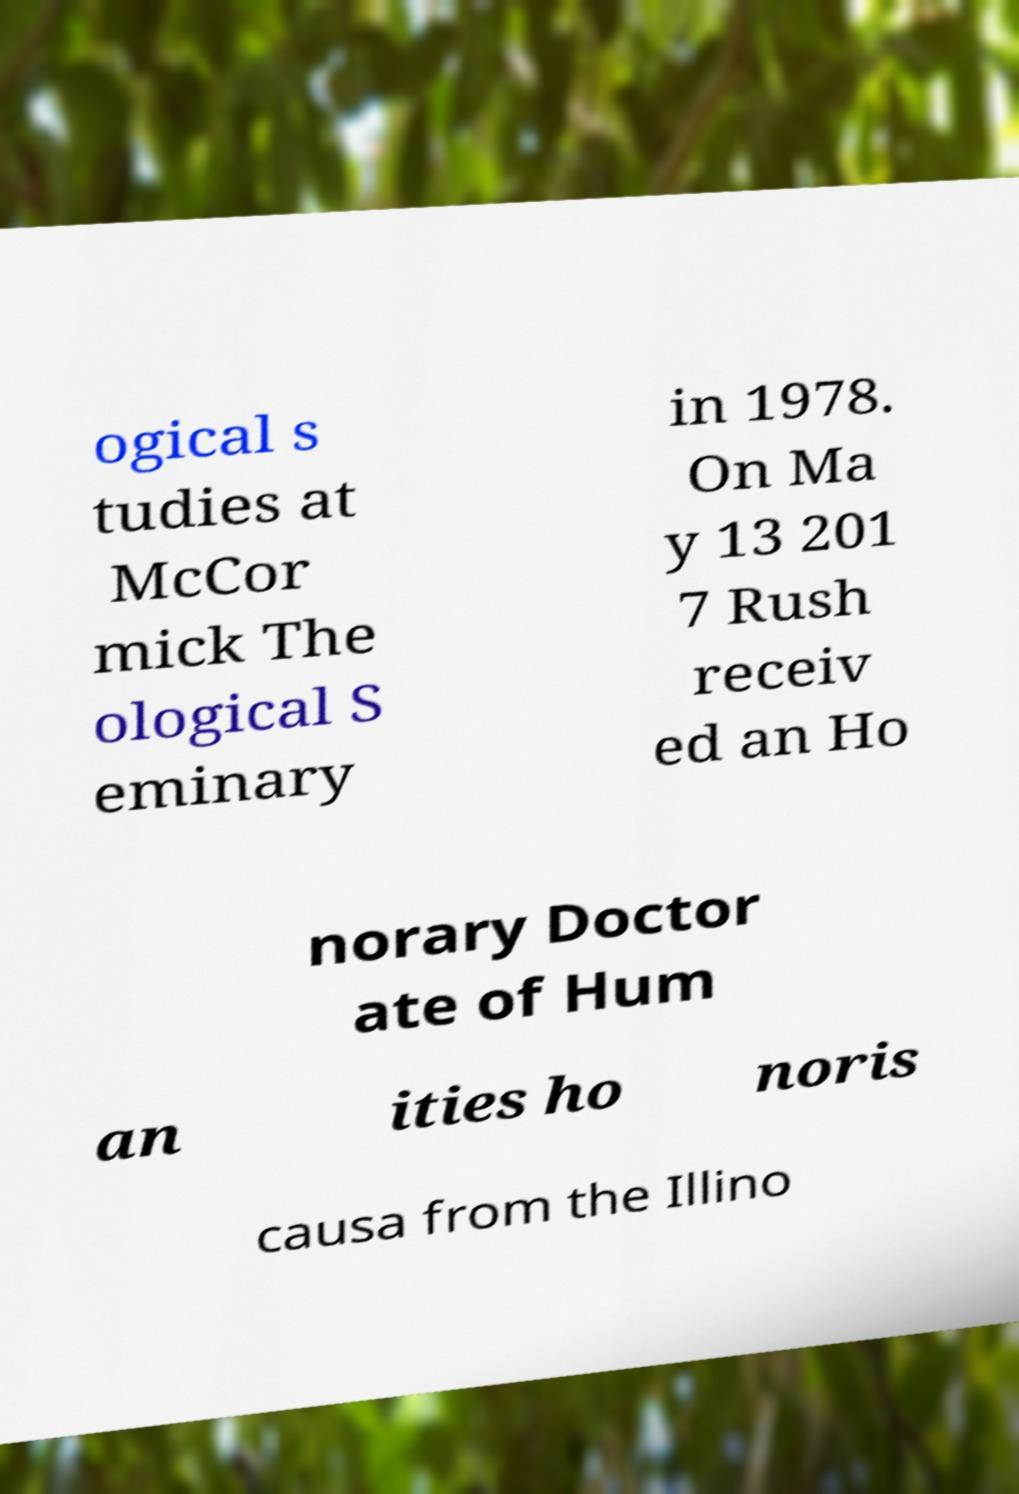Can you accurately transcribe the text from the provided image for me? ogical s tudies at McCor mick The ological S eminary in 1978. On Ma y 13 201 7 Rush receiv ed an Ho norary Doctor ate of Hum an ities ho noris causa from the Illino 